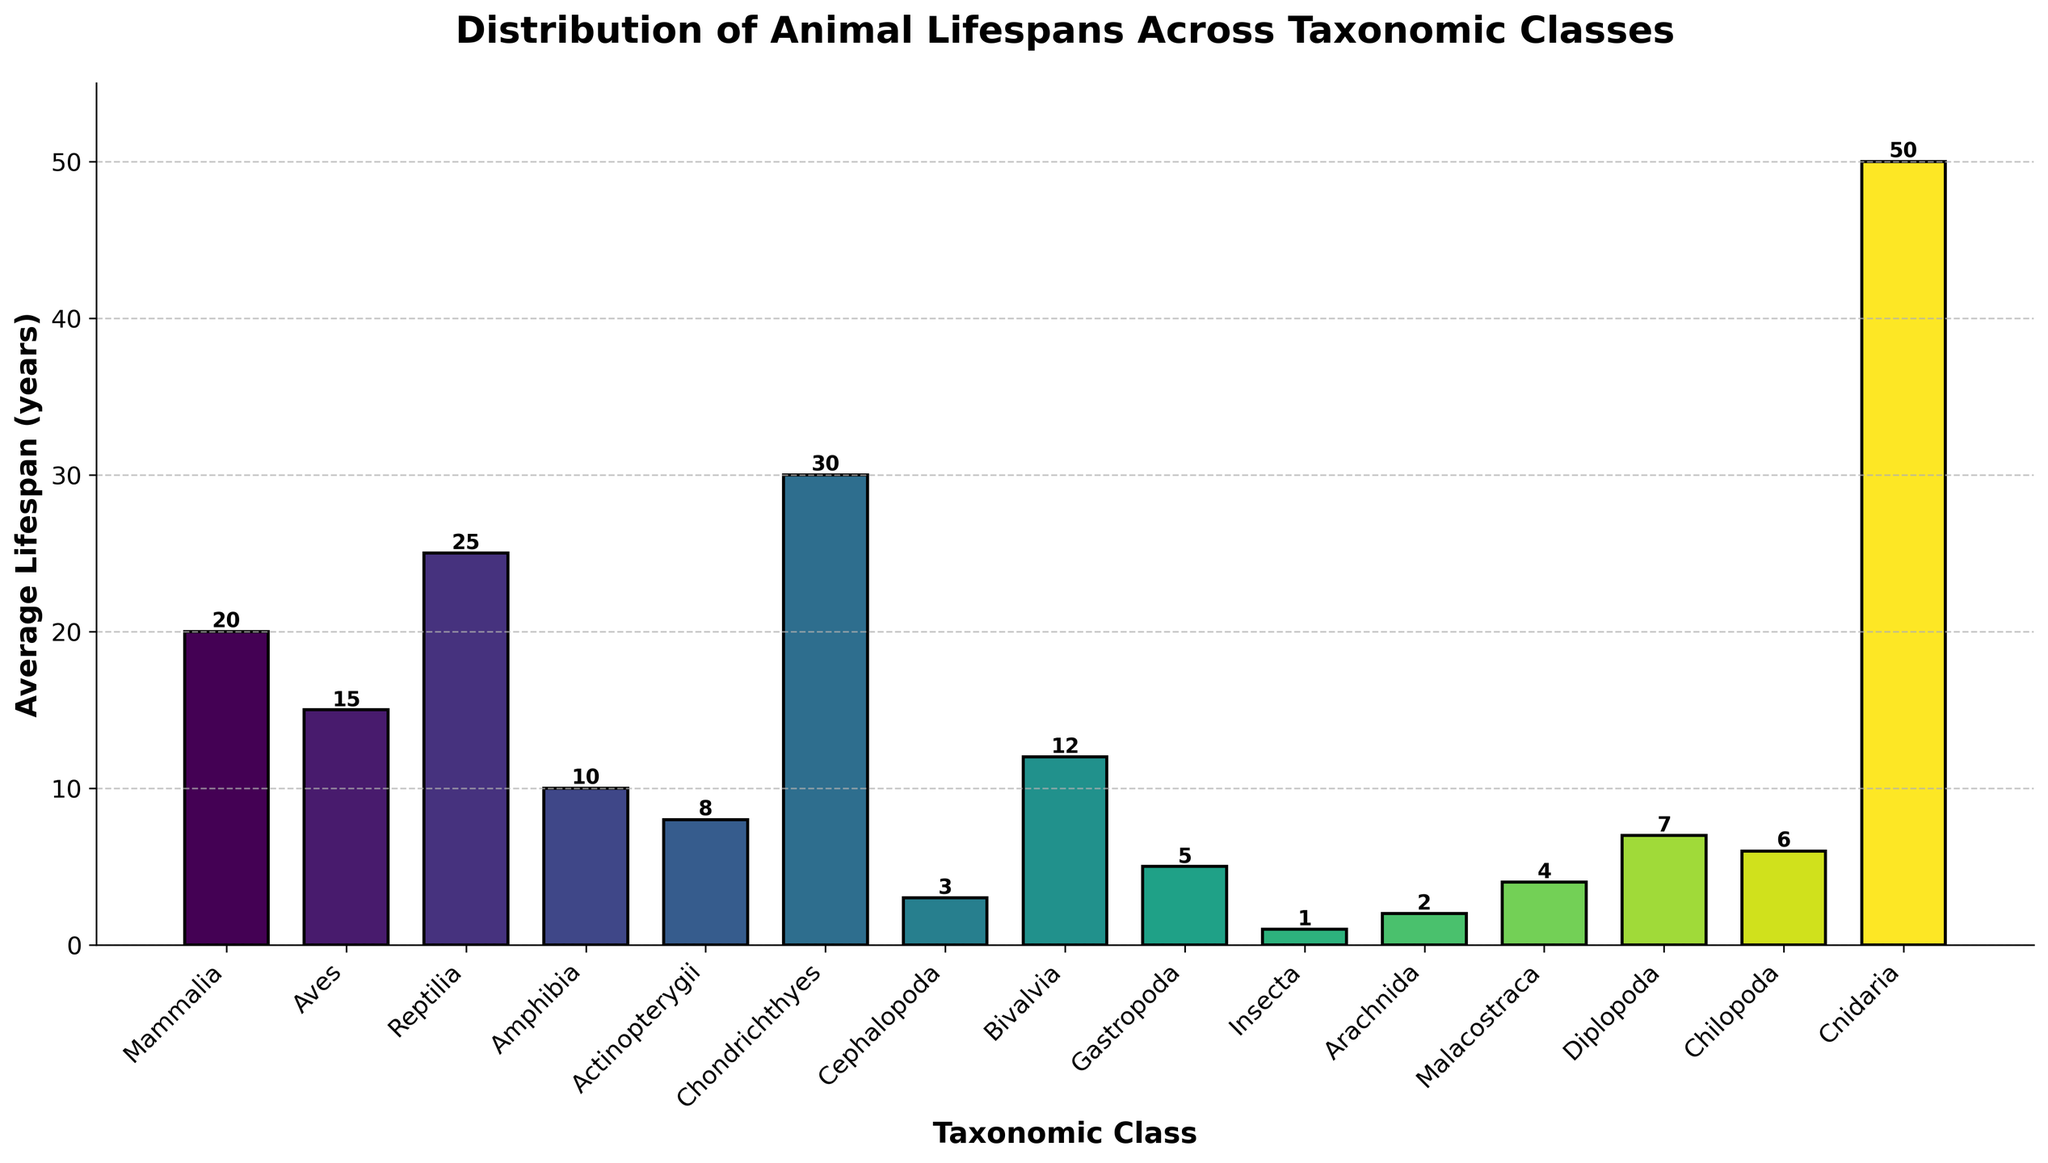Which taxonomic class has the longest average lifespan? The bar representing "Cnidaria" is the tallest among all bars in the chart, indicating that it has the longest average lifespan.
Answer: Cnidaria Which taxonomic class has the shortest average lifespan? The bar representing "Insecta" is the shortest among all bars in the chart, indicating that it has the shortest average lifespan.
Answer: Insecta What is the difference in average lifespan between Mammalia and Reptilia? The average lifespan of Mammalia is 20 years, and that of Reptilia is 25 years. The difference is calculated as 25 - 20 = 5 years.
Answer: 5 years Which has a higher average lifespan, Aves or Chondrichthyes? The bar for "Chondrichthyes" is taller than the bar for "Aves," indicating that Chondrichthyes has a higher average lifespan.
Answer: Chondrichthyes What is the combined average lifespan of Gastropoda, Cephalopoda, and Arachnida? The average lifespans are 5 years for Gastropoda, 3 years for Cephalopoda, and 2 years for Arachnida. The combined average lifespan is calculated as 5 + 3 + 2 = 10 years.
Answer: 10 years Which taxonomic class has an average lifespan closest to 10 years? The bar for "Amphibia" is closest to the height representing 10 years, indicating that Amphibia has an average lifespan closest to 10 years.
Answer: Amphibia Which taxonomic class has a lifespan between the ranges of 5 to 10 years? The bars representing "Actinopterygii," "Bivalvia," "Diplopoda," and "Chilopoda" fall within the range of 5 to 10 years, indicating these classes have average lifespans within this range.
Answer: Actinopterygii, Bivalvia, Diplopoda, and Chilopoda How does the average lifespan of Bivalvia compare to Amphibia and Actinopterygii? The average lifespan of Bivalvia (12 years) is greater than both Amphibia (10 years) and Actinopterygii (8 years).
Answer: Greater than both What is the average lifespan for the taxonomic classes with the three highest lifespans? The top three highest lifespans are Cnidaria (50 years), Chondrichthyes (30 years), and Reptilia (25 years). The average is calculated as (50 + 30 + 25) / 3 ≈ 35 years.
Answer: 35 years 